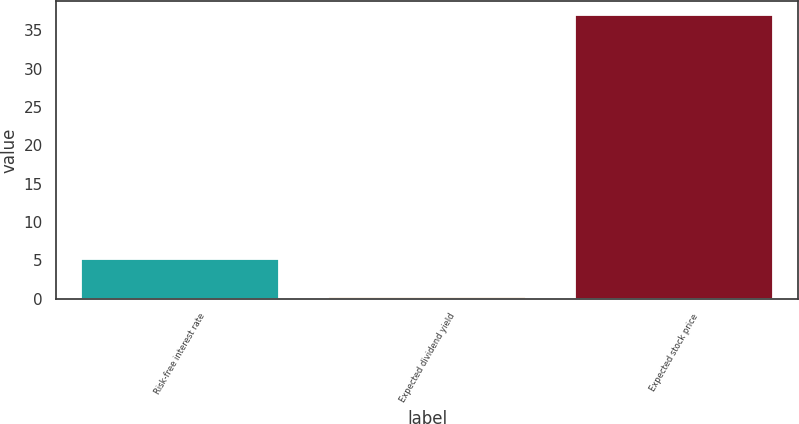Convert chart. <chart><loc_0><loc_0><loc_500><loc_500><bar_chart><fcel>Risk-free interest rate<fcel>Expected dividend yield<fcel>Expected stock price<nl><fcel>5.17<fcel>0.26<fcel>37<nl></chart> 